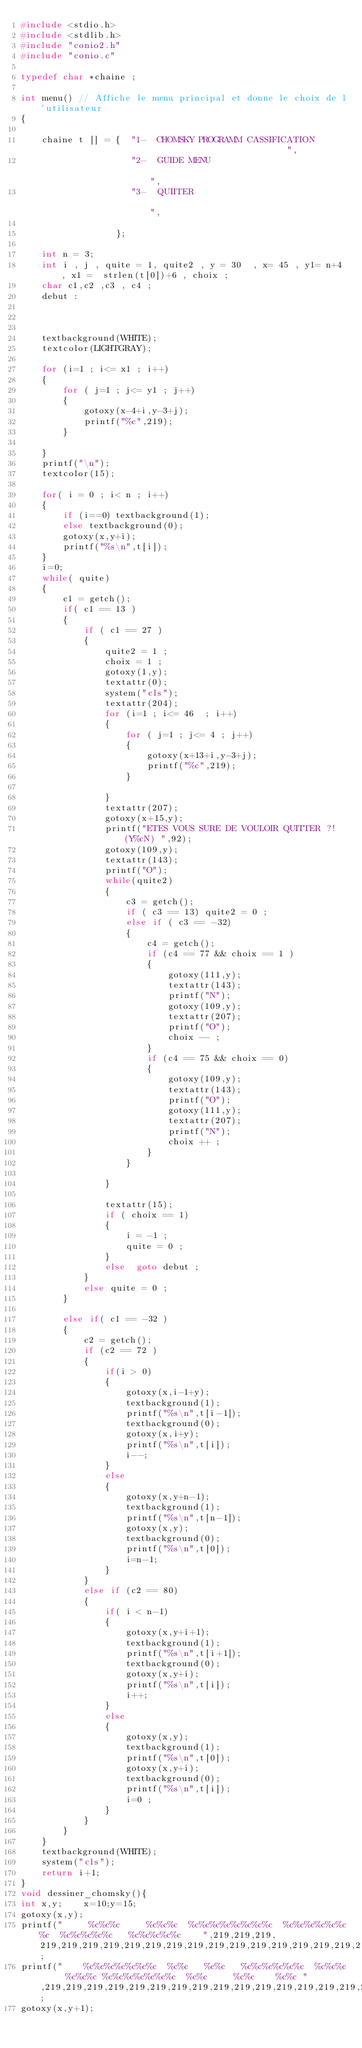Convert code to text. <code><loc_0><loc_0><loc_500><loc_500><_C_>#include <stdio.h>
#include <stdlib.h>
#include "conio2.h"
#include "conio.c"

typedef char *chaine ;

int menu() // Affiche le menu principal et donne le choix de l'utilisateur
{

    chaine t [] = {  "1-  CHOMSKY PROGRAMM CASSIFICATION                                            ",
                     "2-  GUIDE MENU                                                                ",
                     "3-  QUIITER                                                                   ",

                  };

    int n = 3;
    int i , j , quite = 1, quite2 , y = 30  , x= 45 , y1= n+4 , x1 =  strlen(t[0])+6 , choix ;
    char c1,c2 ,c3 , c4 ;
    debut :



    textbackground(WHITE);
    textcolor(LIGHTGRAY);

    for (i=1 ; i<= x1 ; i++)
    {
        for ( j=1 ; j<= y1 ; j++)
        {
            gotoxy(x-4+i,y-3+j);
            printf("%c",219);
        }

    }
    printf("\n");
    textcolor(15);

    for( i = 0 ; i< n ; i++)
    {
        if (i==0) textbackground(1);
        else textbackground(0);
        gotoxy(x,y+i);
        printf("%s\n",t[i]);
    }
    i=0;
    while( quite)
    {
        c1 = getch();
        if( c1 == 13 )
        {
            if ( c1 == 27 )
            {
                quite2 = 1 ;
                choix = 1 ;
                gotoxy(1,y);
                textattr(0);
                system("cls");
                textattr(204);
                for (i=1 ; i<= 46  ; i++)
                {
                    for ( j=1 ; j<= 4 ; j++)
                    {
                        gotoxy(x+13+i,y-3+j);
                        printf("%c",219);
                    }

                }
                textattr(207);
                gotoxy(x+15,y);
                printf("ETES VOUS SURE DE VOULOIR QUITTER ?!  (Y%cN) ",92);
                gotoxy(109,y);
                textattr(143);
                printf("O");
                while(quite2)
                {
                    c3 = getch();
                    if ( c3 == 13) quite2 = 0 ;
                    else if ( c3 == -32)
                    {
                        c4 = getch();
                        if (c4 == 77 && choix == 1 )
                        {
                            gotoxy(111,y);
                            textattr(143);
                            printf("N");
                            gotoxy(109,y);
                            textattr(207);
                            printf("O");
                            choix -- ;
                        }
                        if (c4 == 75 && choix == 0)
                        {
                            gotoxy(109,y);
                            textattr(143);
                            printf("O");
                            gotoxy(111,y);
                            textattr(207);
                            printf("N");
                            choix ++ ;
                        }
                    }

                }

                textattr(15);
                if ( choix == 1)
                {
                    i = -1 ;
                    quite = 0 ;
                }
                else  goto debut ;
            }
            else quite = 0 ;
        }

        else if( c1 == -32 )
        {
            c2 = getch();
            if (c2 == 72 )
            {
                if(i > 0)
                {
                    gotoxy(x,i-1+y);
                    textbackground(1);
                    printf("%s\n",t[i-1]);
                    textbackground(0);
                    gotoxy(x,i+y);
                    printf("%s\n",t[i]);
                    i--;
                }
                else
                {
                    gotoxy(x,y+n-1);
                    textbackground(1);
                    printf("%s\n",t[n-1]);
                    gotoxy(x,y);
                    textbackground(0);
                    printf("%s\n",t[0]);
                    i=n-1;
                }
            }
            else if (c2 == 80)
            {
                if( i < n-1)
                {
                    gotoxy(x,y+i+1);
                    textbackground(1);
                    printf("%s\n",t[i+1]);
                    textbackground(0);
                    gotoxy(x,y+i);
                    printf("%s\n",t[i]);
                    i++;
                }
                else
                {
                    gotoxy(x,y);
                    textbackground(1);
                    printf("%s\n",t[0]);
                    gotoxy(x,y+i);
                    textbackground(0);
                    printf("%s\n",t[i]);
                    i=0 ;
                }
            }
        }
    }
    textbackground(WHITE);
    system("cls");
    return i+1;
}
void dessiner_chomsky(){
int x,y;    x=10;y=15;
gotoxy(x,y);
printf("     %c%c%c     %c%c%c  %c%c%c%c%c%c%c%c  %c%c%c%c%c%c%c  %c%c%c%c%c   %c%c%c%c%c    ",219,219,219, 219,219,219,219,219,219,219,219,219,219,219,219,219,219,219,219,219,219,219,219,219,219,219,219,219,219,219,219);
printf("    %c%c%c%c%c%c%c  %c%c   %c%c   %c%c%c%c%c%c  %c%c%c     %c%c%c %c%c%c%c%c%c%c  %c%c     %c%c    %c%c ",219,219,219,219,219,219,219,219,219,219,219,219,219,219,219,219,219,219,219,219,219,219,219,219,219,219,219,219,219,219,219,219,219,219,219,219);
gotoxy(x,y+1);</code> 